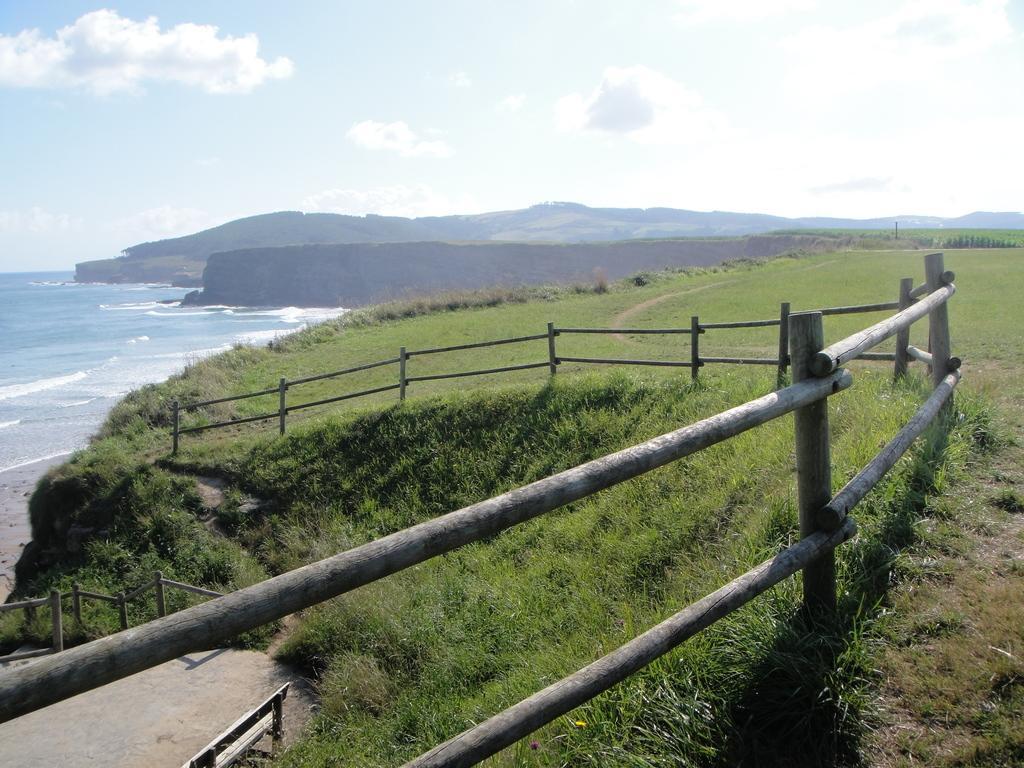Please provide a concise description of this image. In the foreground of the picture there are shrubs, grass and fencing. On the left there is a bench. On the left there is a water body. In the center of the background there are hills. On the right there are plants and grass. In the center of the image there are shrubs and grass. Sky is sunny and it is bit cloudy. 